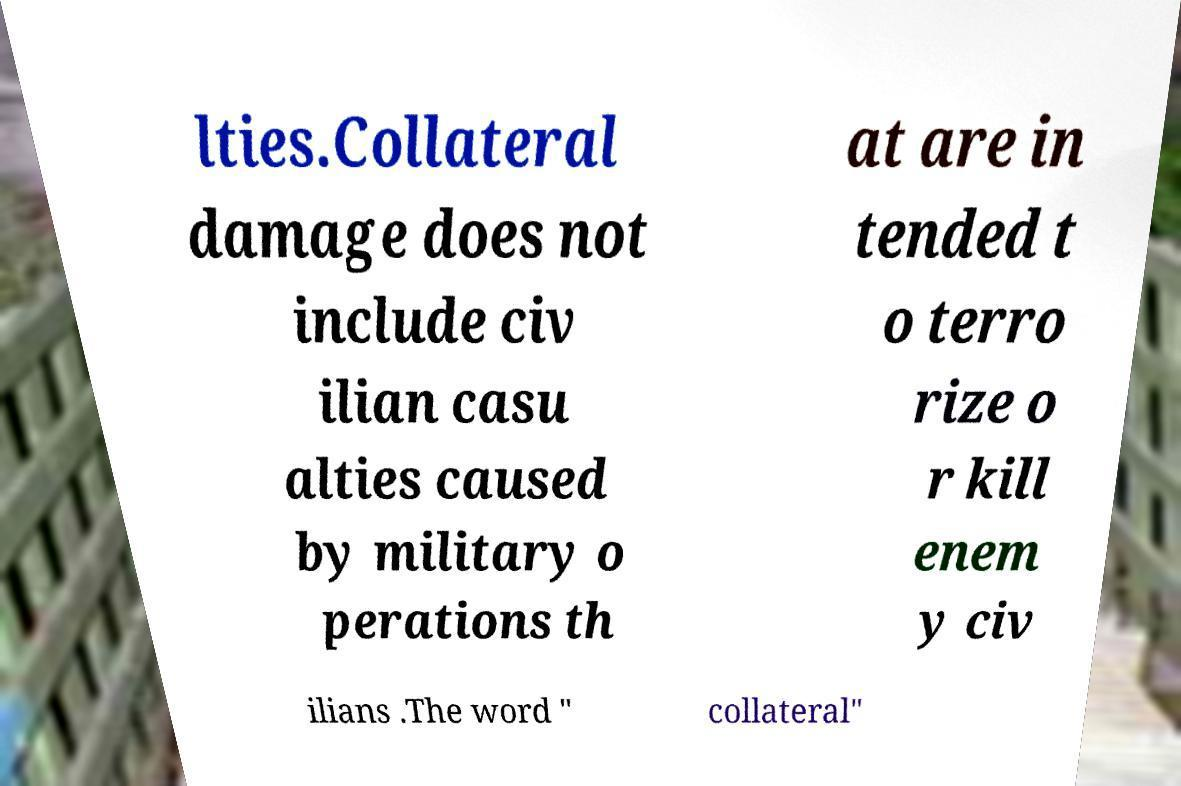Can you accurately transcribe the text from the provided image for me? lties.Collateral damage does not include civ ilian casu alties caused by military o perations th at are in tended t o terro rize o r kill enem y civ ilians .The word " collateral" 